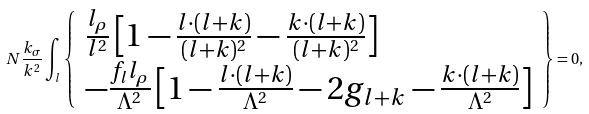Convert formula to latex. <formula><loc_0><loc_0><loc_500><loc_500>N \frac { k _ { \sigma } } { k ^ { 2 } } \int _ { l } \left \{ \begin{array} { l } \frac { l _ { \rho } } { l ^ { 2 } } \left [ 1 - \frac { l \cdot ( l + k ) } { ( l + k ) ^ { 2 } } - \frac { k \cdot ( l + k ) } { ( l + k ) ^ { 2 } } \right ] \\ - \frac { f _ { l } l _ { \rho } } { \Lambda ^ { 2 } } \left [ 1 - \frac { l \cdot ( l + k ) } { \Lambda ^ { 2 } } - 2 g _ { l + k } - \frac { k \cdot ( l + k ) } { \Lambda ^ { 2 } } \right ] \end{array} \right \} = 0 ,</formula> 